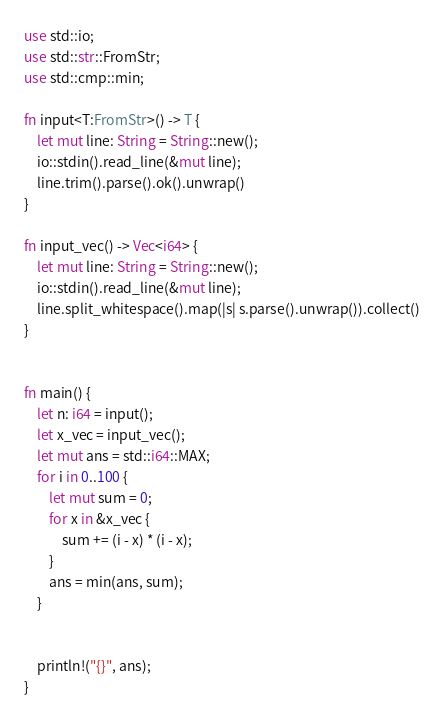<code> <loc_0><loc_0><loc_500><loc_500><_Rust_>use std::io;
use std::str::FromStr;
use std::cmp::min;

fn input<T:FromStr>() -> T {
    let mut line: String = String::new();
    io::stdin().read_line(&mut line);
    line.trim().parse().ok().unwrap()
}

fn input_vec() -> Vec<i64> {
    let mut line: String = String::new();
    io::stdin().read_line(&mut line);
    line.split_whitespace().map(|s| s.parse().unwrap()).collect()
}


fn main() {
    let n: i64 = input();
    let x_vec = input_vec();
    let mut ans = std::i64::MAX;
    for i in 0..100 {
        let mut sum = 0;
        for x in &x_vec {
            sum += (i - x) * (i - x);
        }
        ans = min(ans, sum);
    }


    println!("{}", ans);
}
</code> 